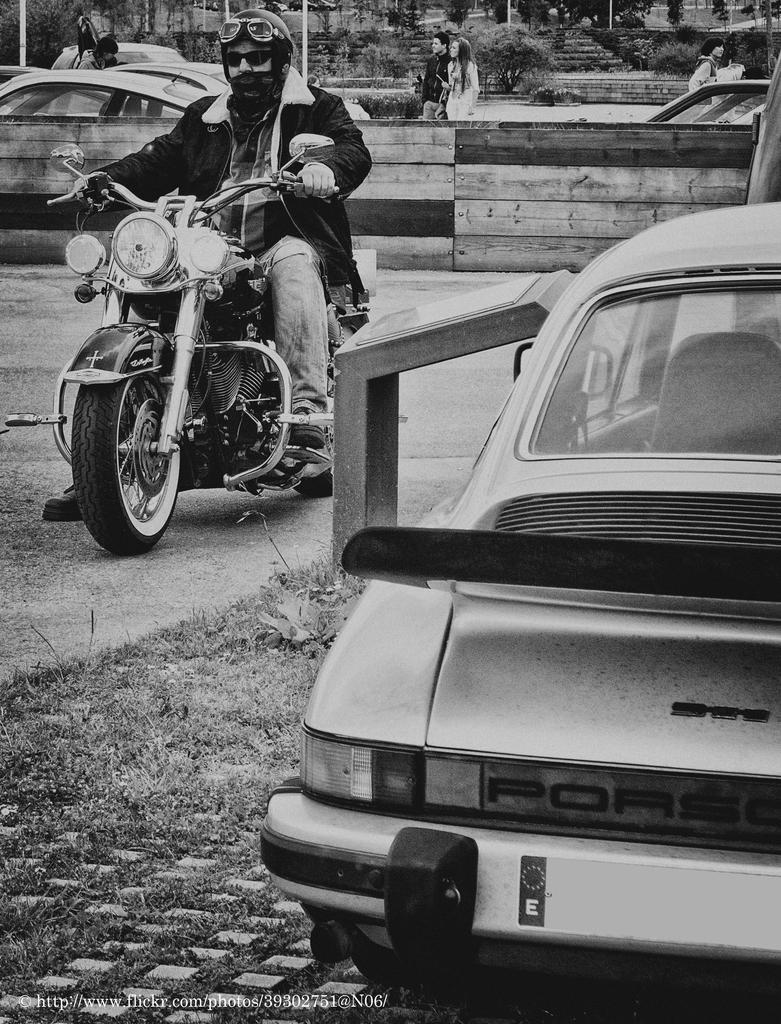What is the man in the image doing? The man is riding a motorcycle in the image. Are there any other people in the image? Yes, there are people standing nearby in the image. What else can be seen in the background of the image? There are parked cars on the side in the image. What type of writing can be seen on the motorcycle in the image? There is no writing visible on the motorcycle in the image. Are there any sticks present in the image? There are no sticks visible in the image. 